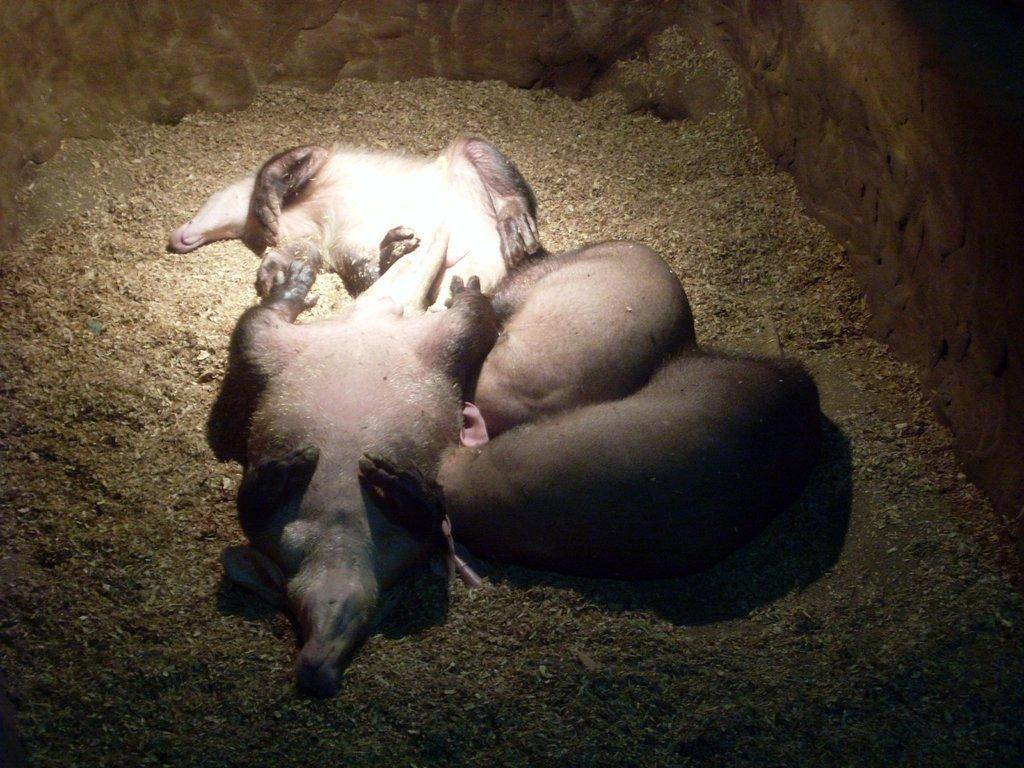How many animals are present in the image? There are four animals in the image. Where are the animals located in the image? The animals are on the ground and wall in the image. Can you describe the time of day when the image was taken? The image may have been taken during the night, as there is no indication of daylight. What type of hose is being used to water the cabbage in the image? There is no hose or cabbage present in the image; it features four animals on the ground and wall. How many rolls are visible in the image? There are no rolls present in the image. 